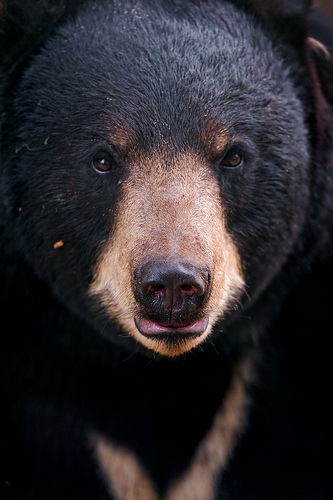Please provide the bounding box coordinate of the region this sentence describes: pink area inside the bears nostril. The bounding box coordinates for the pink area inside the bear's nostril are [0.53, 0.56, 0.56, 0.6]. The area is small and likely highlighted by the contrast against the darker colors of the bear's fur. 